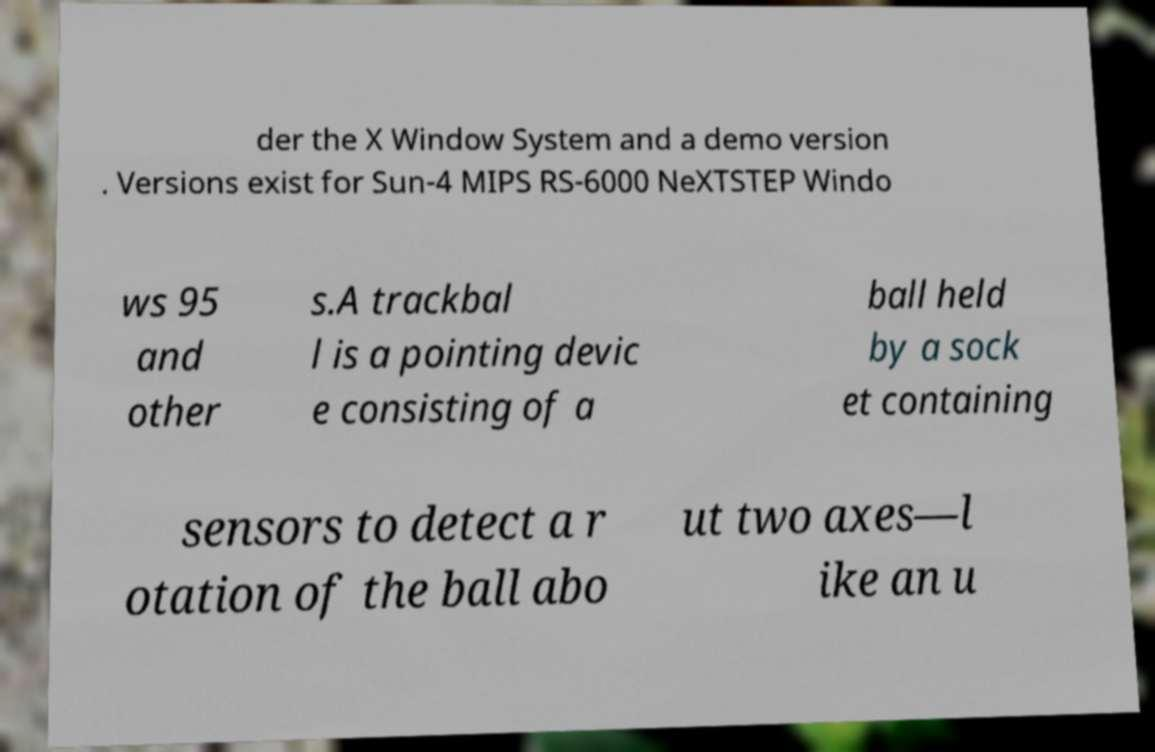What messages or text are displayed in this image? I need them in a readable, typed format. der the X Window System and a demo version . Versions exist for Sun-4 MIPS RS-6000 NeXTSTEP Windo ws 95 and other s.A trackbal l is a pointing devic e consisting of a ball held by a sock et containing sensors to detect a r otation of the ball abo ut two axes—l ike an u 